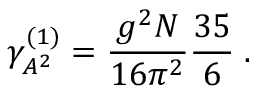<formula> <loc_0><loc_0><loc_500><loc_500>\gamma _ { A ^ { 2 } } ^ { ( 1 ) } = \frac { g ^ { 2 } N } { 1 6 \pi ^ { 2 } } \frac { 3 5 } { 6 } \, .</formula> 